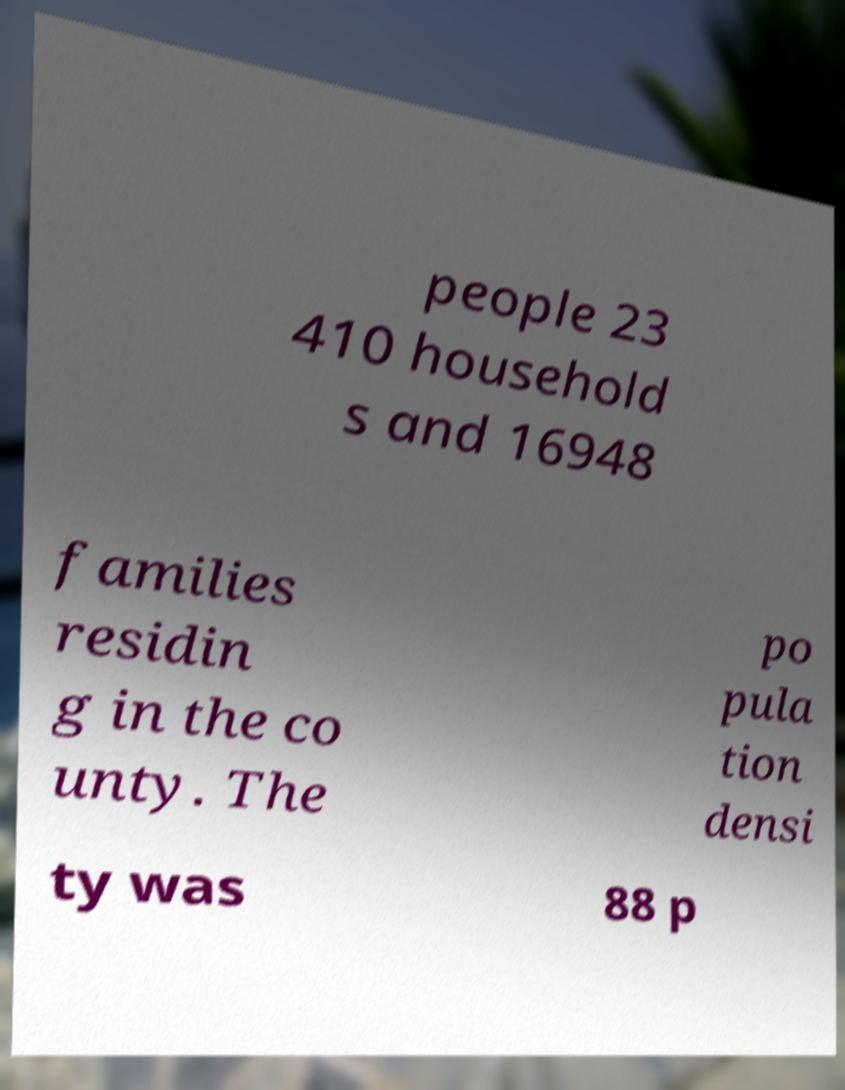Can you accurately transcribe the text from the provided image for me? people 23 410 household s and 16948 families residin g in the co unty. The po pula tion densi ty was 88 p 